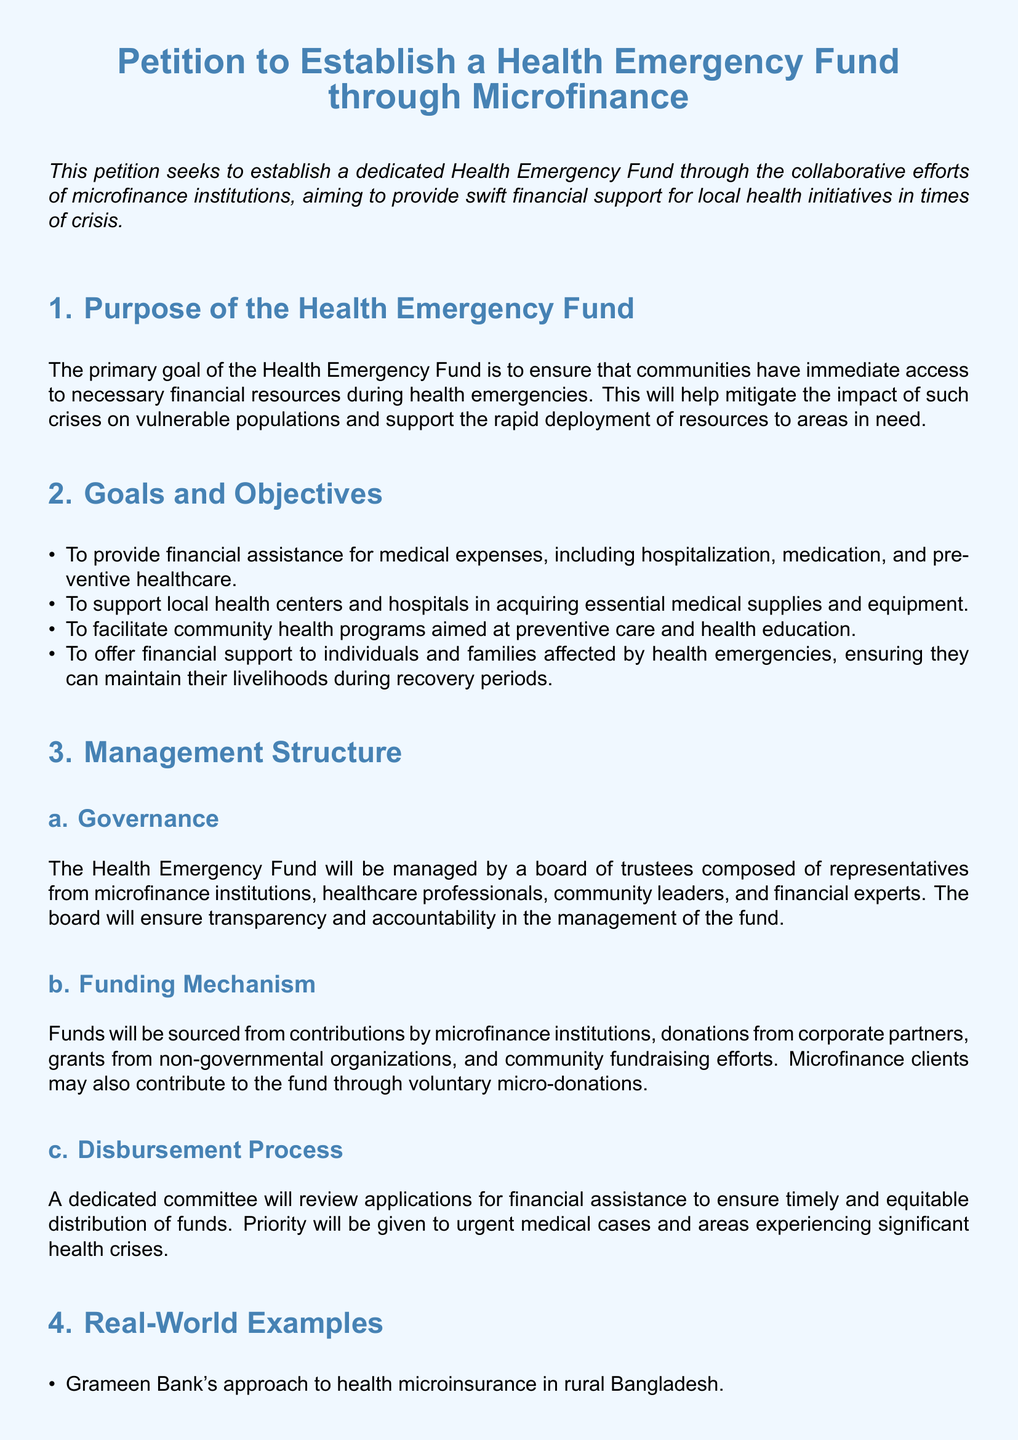What is the primary goal of the Health Emergency Fund? The primary goal is to ensure that communities have immediate access to necessary financial resources during health emergencies.
Answer: ensure immediate access to financial resources What types of financial assistance will the fund provide? The fund will provide financial assistance for medical expenses, acquisition of medical supplies, and support for individuals affected by health emergencies.
Answer: medical expenses, supplies, support for affected individuals Who will manage the Health Emergency Fund? The fund will be managed by a board of trustees composed of representatives from various sectors including microfinance institutions and healthcare professionals.
Answer: a board of trustees What will be the source of the fund? The fund will be sourced from contributions by microfinance institutions, corporate donations, and community fundraising efforts.
Answer: contributions and donations Which healthcare initiatives are referenced as real-world examples in the petition? The petition mentions Grameen Bank's health microinsurance approach and microfinance initiatives during the Ebola outbreak.
Answer: Grameen Bank and Ebola initiatives What is the priority for disbursement of funds? Priority will be given to urgent medical cases and areas experiencing significant health crises.
Answer: urgent medical cases What is the call to action in the petition? The call to action urges stakeholders to support the creation of the Health Emergency Fund.
Answer: support creation of the fund How will applications for financial assistance be reviewed? A dedicated committee will review applications to ensure timely and equitable distribution of funds.
Answer: through a dedicated committee 